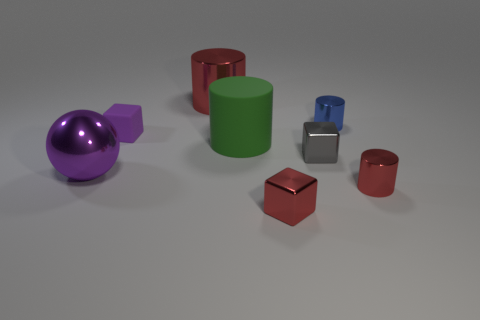What material is the block that is the same color as the big sphere?
Your response must be concise. Rubber. How many other matte cylinders have the same color as the matte cylinder?
Your answer should be very brief. 0. Are there the same number of cylinders that are behind the gray metal thing and big purple shiny spheres?
Provide a short and direct response. No. The ball is what color?
Ensure brevity in your answer.  Purple. The blue cylinder that is the same material as the small gray cube is what size?
Your answer should be very brief. Small. There is a block that is the same material as the large green cylinder; what is its color?
Offer a very short reply. Purple. Are there any other rubber things of the same size as the green matte object?
Your response must be concise. No. What is the material of the other large object that is the same shape as the large matte thing?
Make the answer very short. Metal. There is a gray thing that is the same size as the red block; what shape is it?
Offer a very short reply. Cube. Are there any purple rubber things that have the same shape as the gray metallic thing?
Your response must be concise. Yes. 